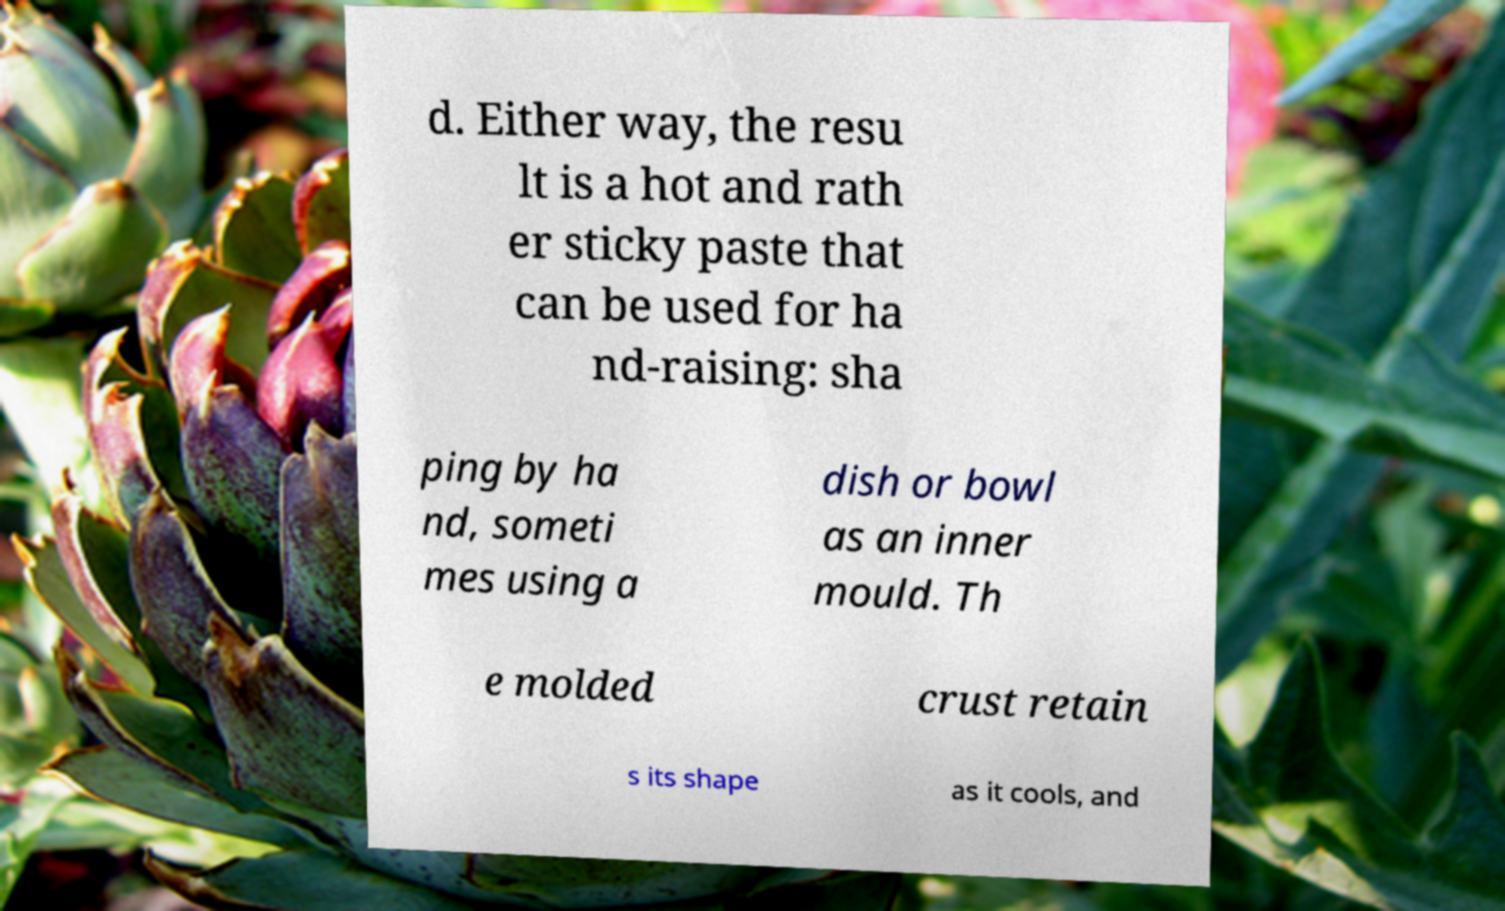Can you read and provide the text displayed in the image?This photo seems to have some interesting text. Can you extract and type it out for me? d. Either way, the resu lt is a hot and rath er sticky paste that can be used for ha nd-raising: sha ping by ha nd, someti mes using a dish or bowl as an inner mould. Th e molded crust retain s its shape as it cools, and 